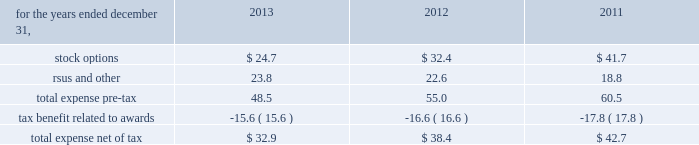Zimmer holdings , inc .
2013 form 10-k annual report notes to consolidated financial statements ( continued ) unrealized gains and losses on cash flow hedges , unrealized gains and losses on available-for-sale securities and amortization of prior service costs and unrecognized gains and losses in actuarial assumptions .
Treasury stock 2013 we account for repurchases of common stock under the cost method and present treasury stock as a reduction of stockholders 2019 equity .
We reissue common stock held in treasury only for limited purposes .
Noncontrolling interest 2013 in 2011 , we made an investment in a company in which we acquired a controlling financial interest , but not 100 percent of the equity .
In 2013 , we purchased additional shares of the company from the minority shareholders .
Further information related to the noncontrolling interests of that investment has not been provided as it is not significant to our consolidated financial statements .
Accounting pronouncements 2013 effective january 1 , 2013 , we adopted the fasb 2019s accounting standard updates ( asus ) requiring reporting of amounts reclassified out of accumulated other comprehensive income ( oci ) and balance sheet offsetting between derivative assets and liabilities .
These asus only change financial statement disclosure requirements and therefore do not impact our financial position , results of operations or cash flows .
See note 12 for disclosures relating to oci .
See note 13 for disclosures relating to balance sheet offsetting .
There are no other recently issued accounting pronouncements that we have not yet adopted that are expected to have a material effect on our financial position , results of operations or cash flows .
Share-based compensation our share-based payments primarily consist of stock options , restricted stock , restricted stock units ( rsus ) , and an employee stock purchase plan .
Share-based compensation expense is as follows ( in millions ) : .
Share-based compensation cost capitalized as part of inventory for the years ended december 31 , 2013 , 2012 and 2011 was $ 4.1 million , $ 6.1 million , and $ 8.8 million , respectively .
As of december 31 , 2013 and 2012 , approximately $ 2.4 million and $ 3.3 million of capitalized costs remained in finished goods inventory .
Stock options we had two equity compensation plans in effect at december 31 , 2013 : the 2009 stock incentive plan ( 2009 plan ) and the stock plan for non-employee directors .
The 2009 plan succeeded the 2006 stock incentive plan ( 2006 plan ) and the teamshare stock option plan ( teamshare plan ) .
No further awards have been granted under the 2006 plan or under the teamshare plan since may 2009 , and shares remaining available for grant under those plans have been merged into the 2009 plan .
Vested and unvested stock options and unvested restricted stock and rsus previously granted under the 2006 plan , the teamshare plan and another prior plan , the 2001 stock incentive plan , remained outstanding as of december 31 , 2013 .
We have reserved the maximum number of shares of common stock available for award under the terms of each of these plans .
We have registered 57.9 million shares of common stock under these plans .
The 2009 plan provides for the grant of nonqualified stock options and incentive stock options , long-term performance awards in the form of performance shares or units , restricted stock , rsus and stock appreciation rights .
The compensation and management development committee of the board of directors determines the grant date for annual grants under our equity compensation plans .
The date for annual grants under the 2009 plan to our executive officers is expected to occur in the first quarter of each year following the earnings announcements for the previous quarter and full year .
The stock plan for non-employee directors provides for awards of stock options , restricted stock and rsus to non-employee directors .
It has been our practice to issue shares of common stock upon exercise of stock options from previously unissued shares , except in limited circumstances where they are issued from treasury stock .
The total number of awards which may be granted in a given year and/or over the life of the plan under each of our equity compensation plans is limited .
At december 31 , 2013 , an aggregate of 10.4 million shares were available for future grants and awards under these plans .
Stock options granted to date under our plans generally vest over four years and generally have a maximum contractual life of 10 years .
As established under our equity compensation plans , vesting may accelerate upon retirement after the first anniversary date of the award if certain criteria are met .
We recognize expense related to stock options on a straight-line basis over the requisite service period , less awards expected to be forfeited using estimated forfeiture rates .
Due to the accelerated retirement provisions , the requisite service period of our stock options range from one to four years .
Stock options are granted with an exercise price equal to the market price of our common stock on the date of grant , except in limited circumstances where local law may dictate otherwise. .
What was the percentage change in share-based compensation expense between 2011 and 2012? 
Computations: ((38.4 - 42.7) / 42.7)
Answer: -0.1007. 